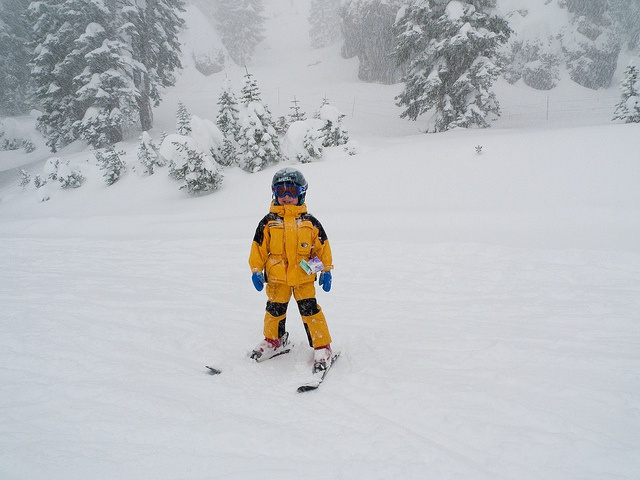Describe the objects in this image and their specific colors. I can see people in gray, orange, and black tones and skis in gray, lightgray, darkgray, and black tones in this image. 